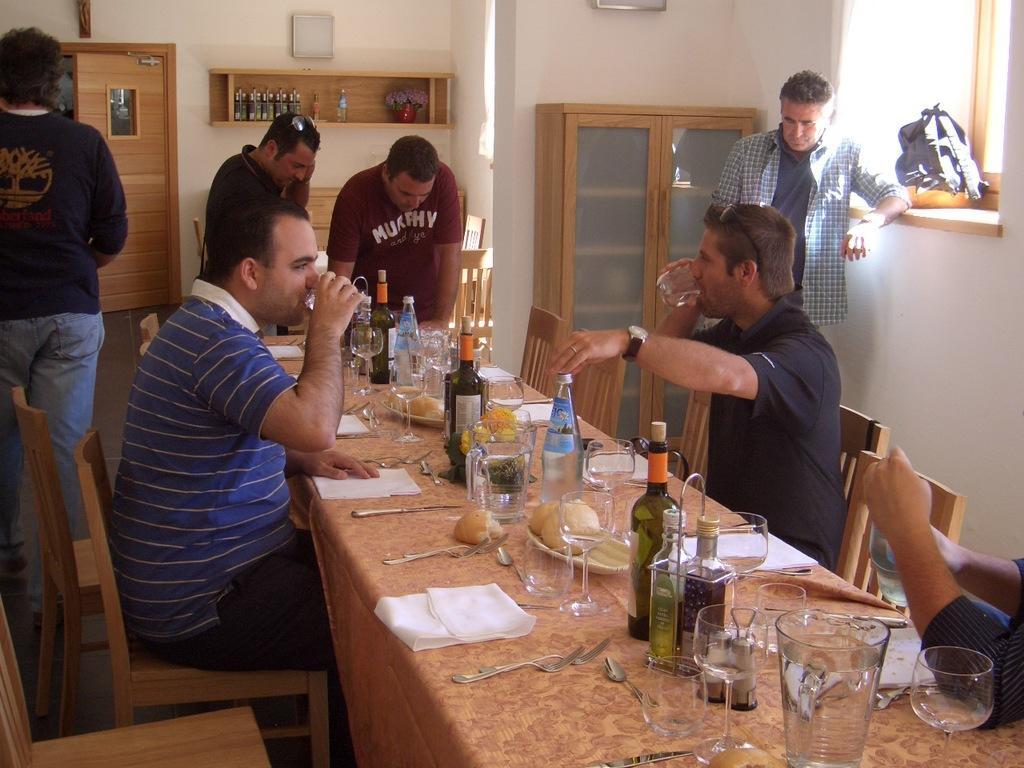In one or two sentences, can you explain what this image depicts? On the background we can see a wall and cupboard and there are bottles and a flower vase. Here we can see persons standing near to the table. We can see persons sitting on chairs in front of a table and on the table we can see bottles, glasses, tissue papers, spoons, forks, food. We can see these two men drinking. 